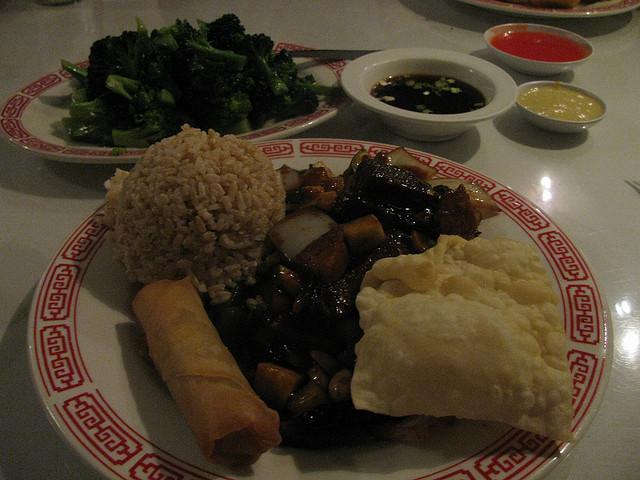How many bowls are there?
Give a very brief answer. 3. 